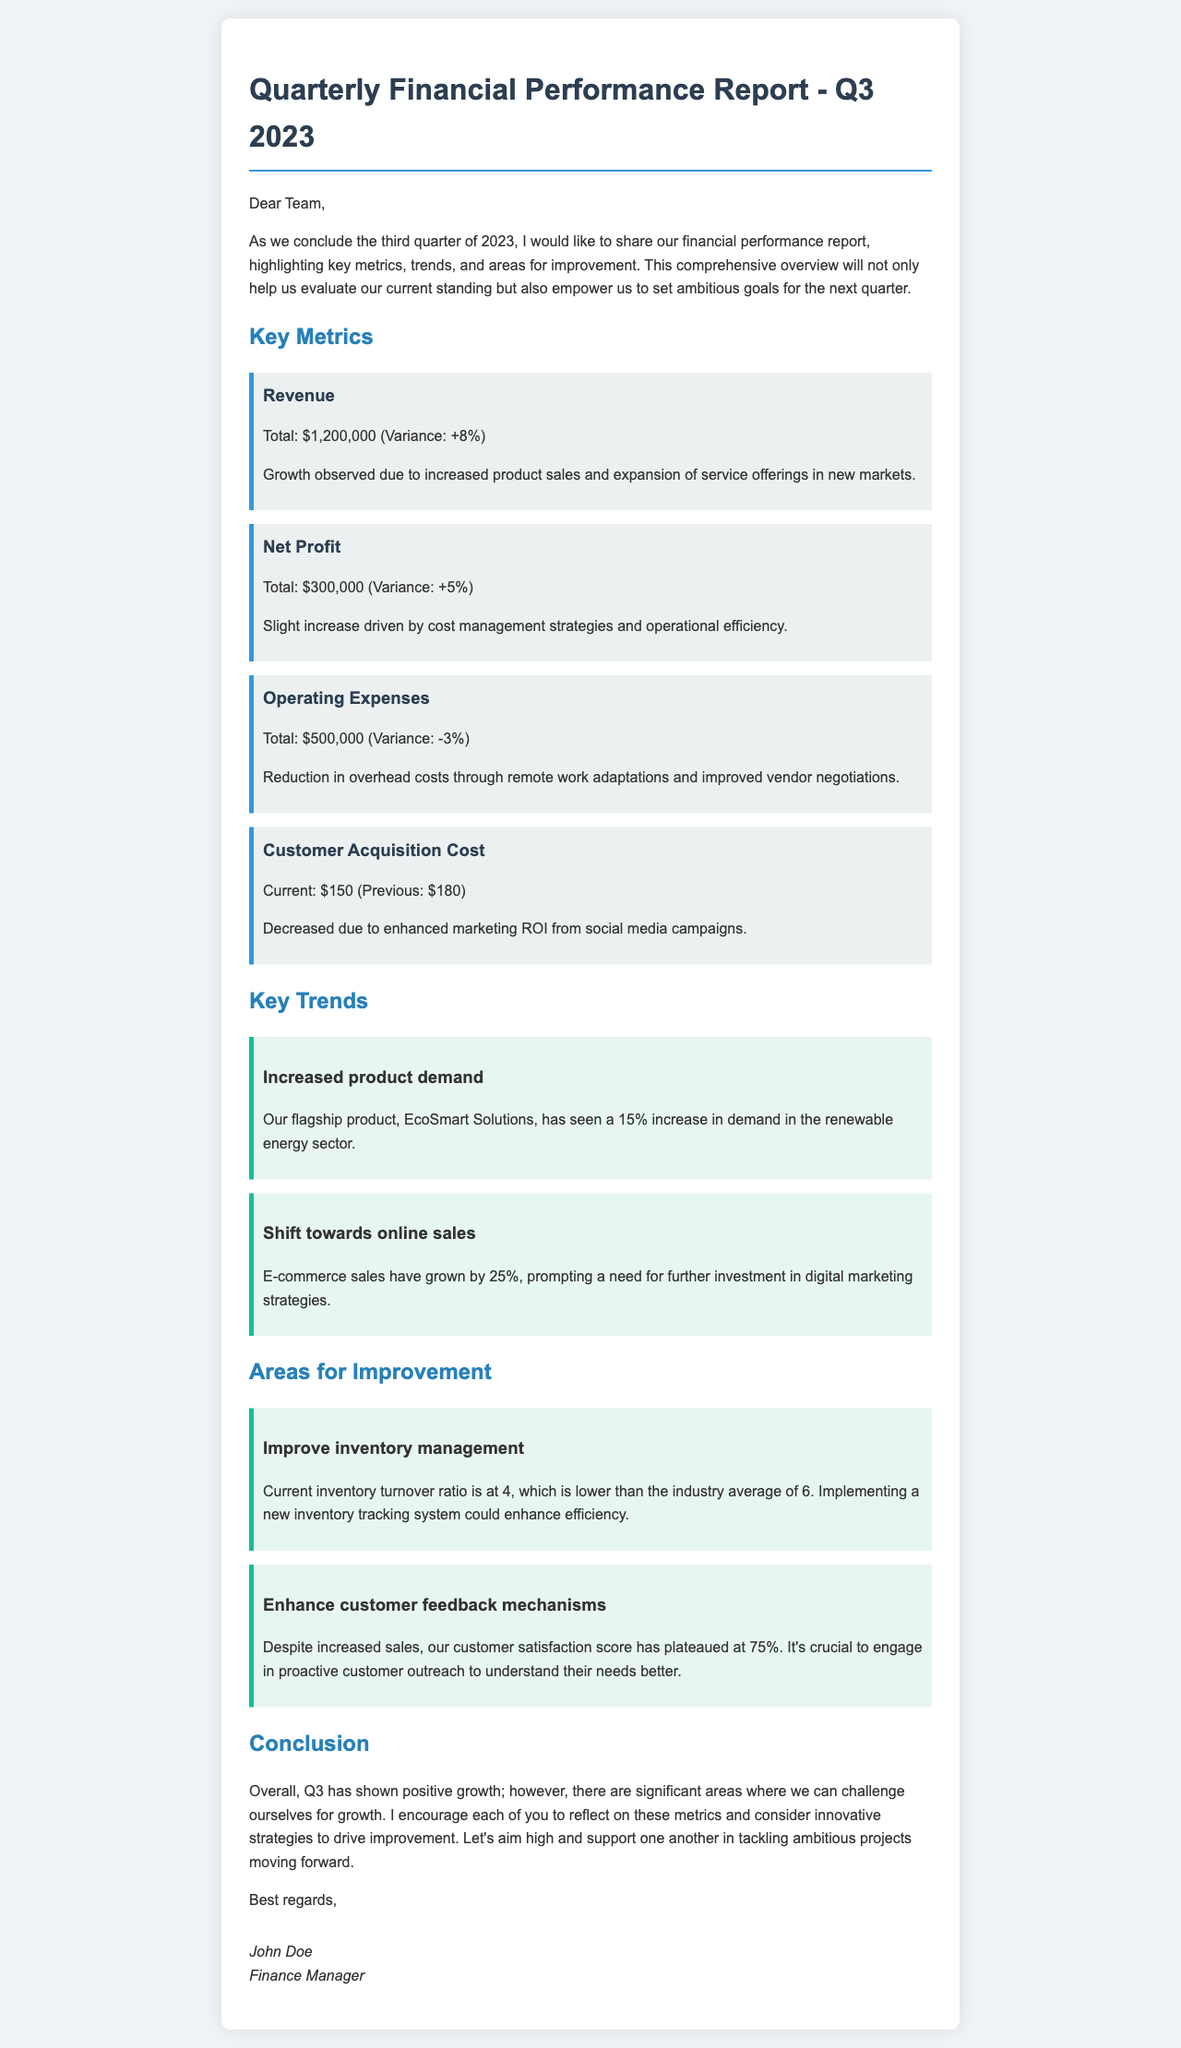What is the total revenue for Q3 2023? The total revenue is explicitly mentioned in the document as $1,200,000.
Answer: $1,200,000 What is the variance for net profit? The variance for net profit is a percentage change noted in the report, which is +5%.
Answer: +5% What is the current customer acquisition cost? The current customer acquisition cost is specified as $150 in the document.
Answer: $150 What is the inventory turnover ratio? The current inventory turnover ratio is indicated in the report as 4.
Answer: 4 What trend is indicated regarding online sales? The document mentions that e-commerce sales have grown by 25%.
Answer: 25% What area needs improvement related to customer feedback? The document highlights the need to enhance customer feedback mechanisms.
Answer: Enhance customer feedback mechanisms What is the total operating expenses reported? Total operating expenses are explicitly stated in the document as $500,000.
Answer: $500,000 What percentage increase in demand is noted for EcoSmart Solutions? The increase in demand for EcoSmart Solutions is noted as 15% in the report.
Answer: 15% Who is the author of the report? The author of the report is mentioned as John Doe.
Answer: John Doe 